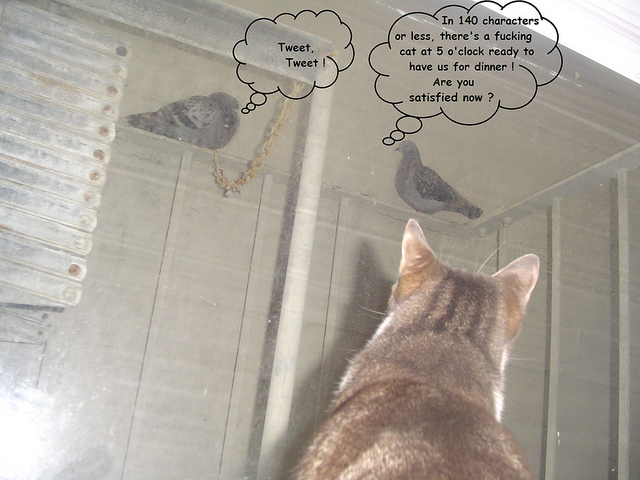Identify the text displayed in this image. Tweet or cat now US ready Tweet dinner for you Are satisfied have at 5 clock o' 10 fucking characters a there's 140 In less 